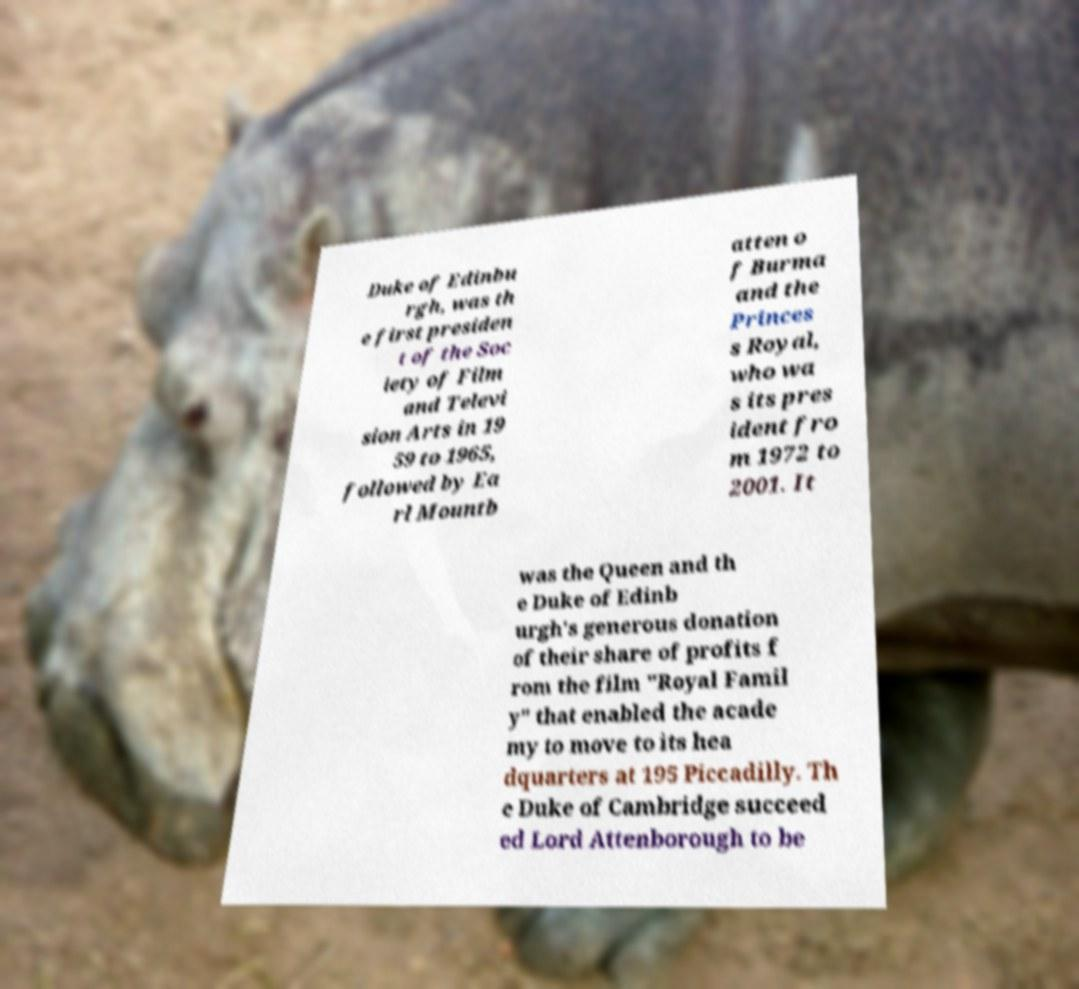What messages or text are displayed in this image? I need them in a readable, typed format. Duke of Edinbu rgh, was th e first presiden t of the Soc iety of Film and Televi sion Arts in 19 59 to 1965, followed by Ea rl Mountb atten o f Burma and the Princes s Royal, who wa s its pres ident fro m 1972 to 2001. It was the Queen and th e Duke of Edinb urgh's generous donation of their share of profits f rom the film "Royal Famil y" that enabled the acade my to move to its hea dquarters at 195 Piccadilly. Th e Duke of Cambridge succeed ed Lord Attenborough to be 